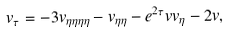Convert formula to latex. <formula><loc_0><loc_0><loc_500><loc_500>v _ { \tau } = - 3 v _ { \eta \eta \eta \eta } - v _ { \eta \eta } - e ^ { 2 \tau } v v _ { \eta } - 2 v ,</formula> 